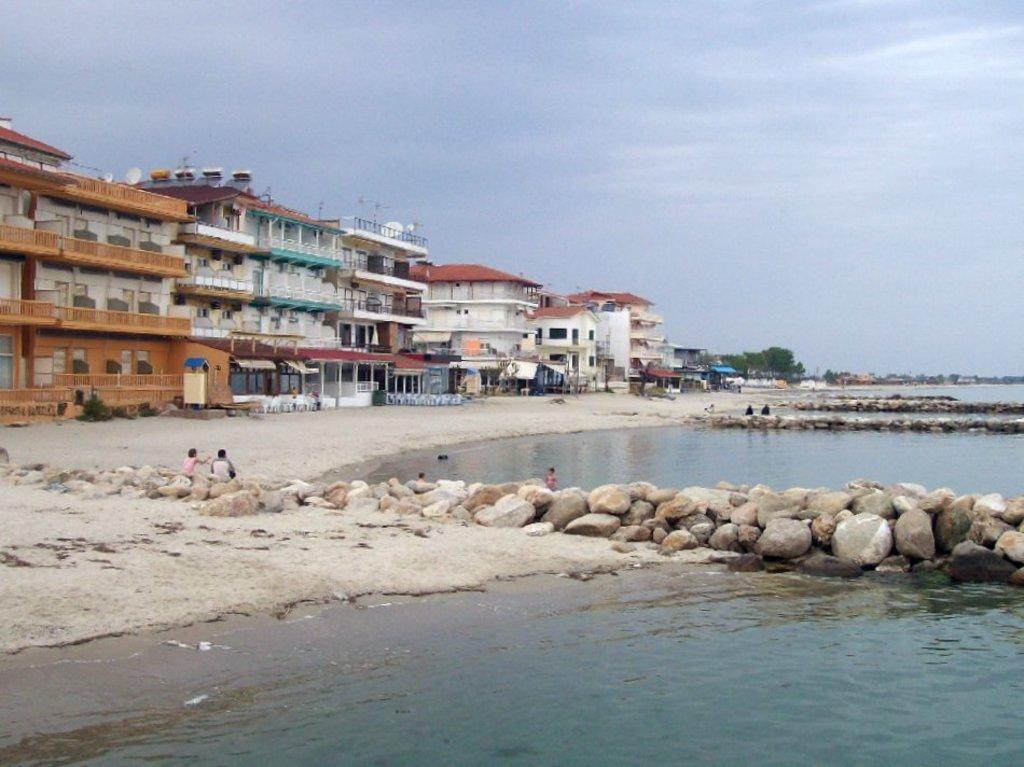How would you summarize this image in a sentence or two? In this image, we can see buildings and trees and we can see some people. At the bottom, there is water and rocks. 